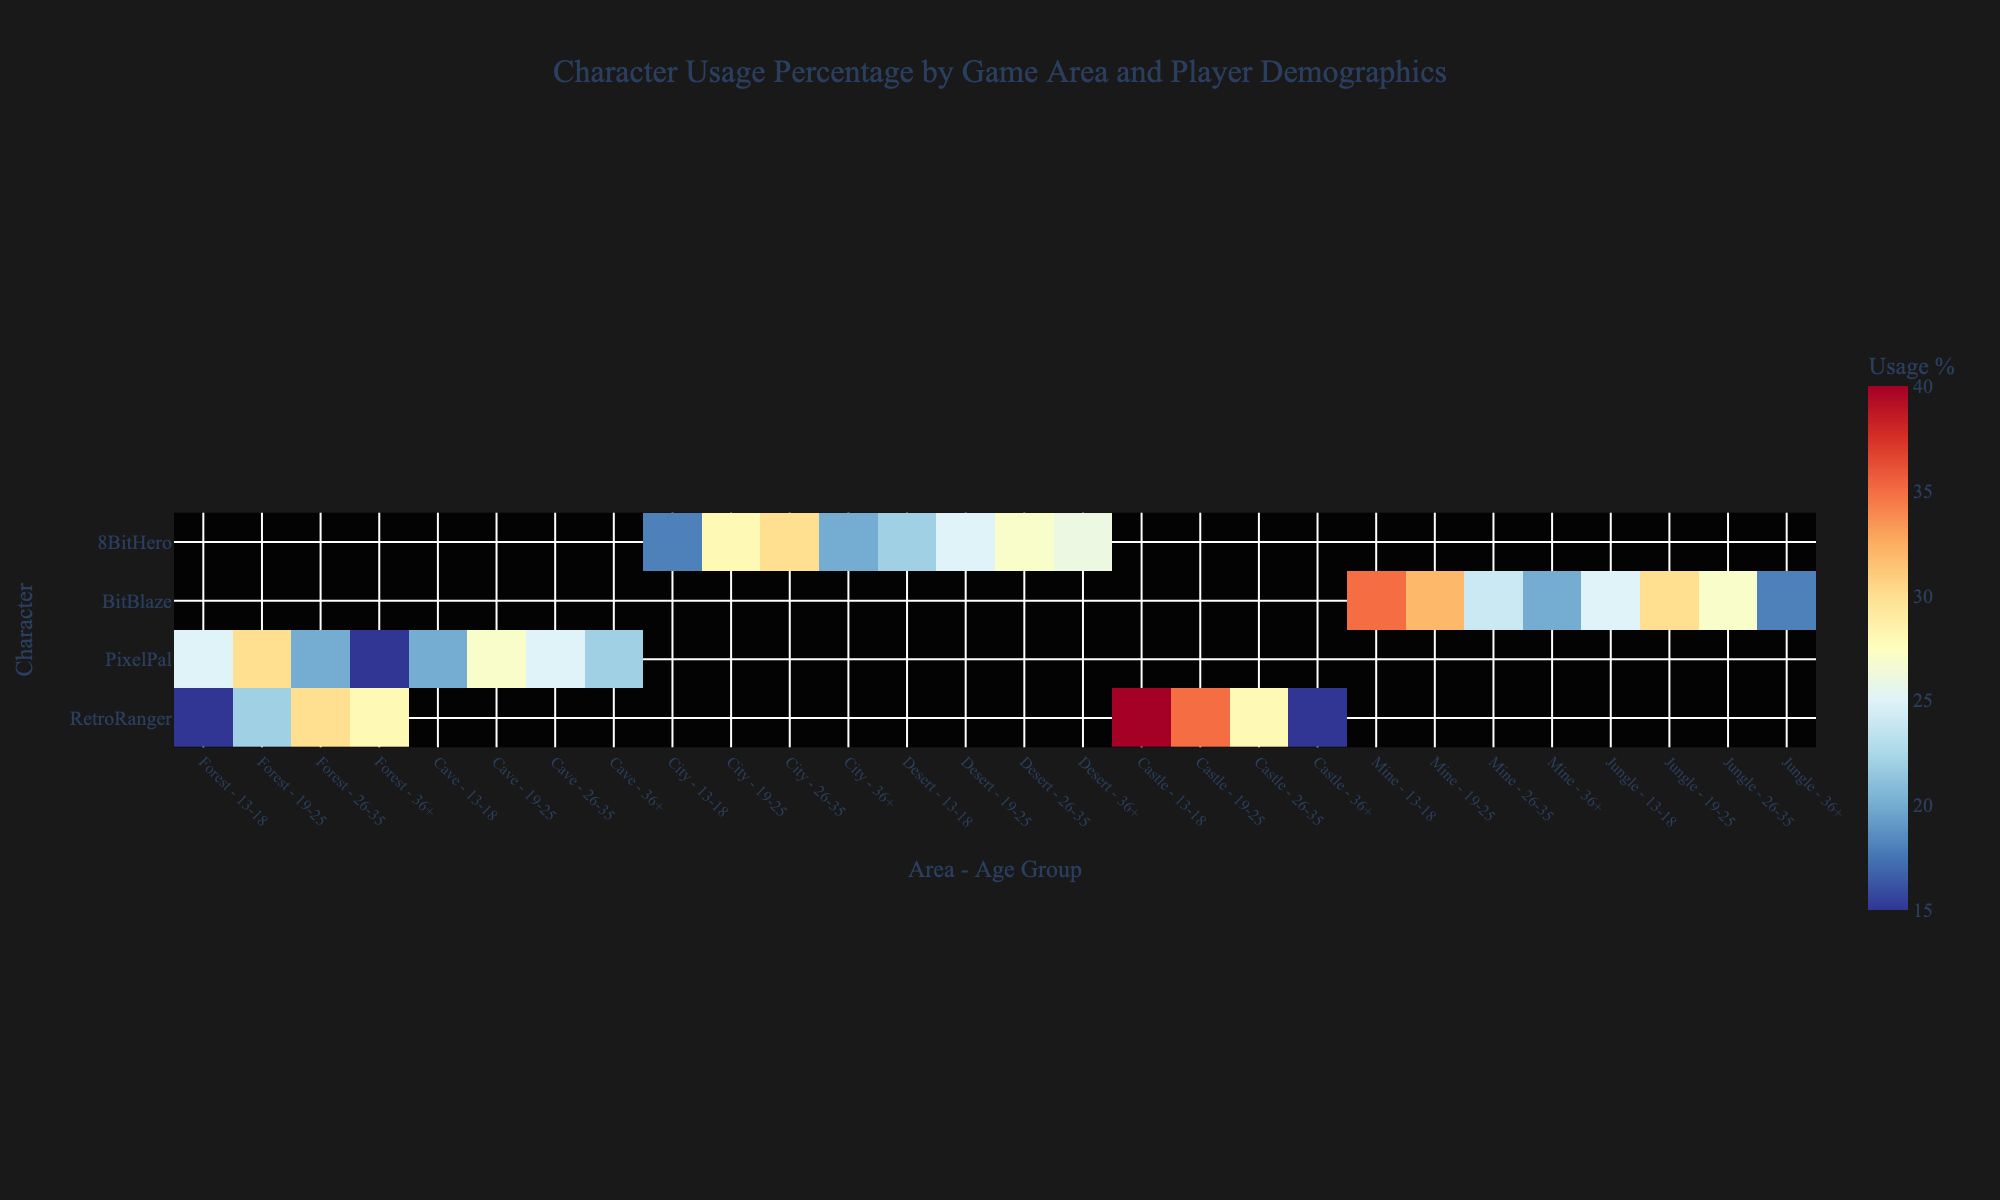What's the overall title of the figure? The title is usually found at the top of the heatmap, describing the main content or purpose of the visualization.
Answer: Character Usage Percentage by Game Area and Player Demographics Which character has the highest usage percentage in the Castle area? Look along the y-axis for 'RetroRanger,' then follow the relevant columns under Castle to find the highest percentage.
Answer: RetroRanger In the Forest area, which age group has the lowest usage percentage for PixelPal? Find the Forest column under PixelPal and compare the different age groups. The group with the lowest value is the one with the lowest usage percentage.
Answer: 36+ For 8BitHero, what's the difference in usage percentage between the youngest and oldest age groups in the City area? Locate 8BitHero and look at the City column. Subtract the usage percentage of the 36+ age group from the 13-18 age group.
Answer: 18 - 20 = -2 Which area shows the highest variability in character usage percentage for the 19-25 age group? Compare the heatmap values across all areas for the 19-25 age group. The area with the most uneven distribution (highest range) shows the highest variability.
Answer: Castle How does PixelPal's popularity in the Cave area compare across different age groups? Look at PixelPal's row and compare the values in the Cave columns for each age group.
Answer: 13-18: 20%, 19-25: 27%, 26-35: 25%, 36+: 22% Which character shows the most significant usage percentage increase when comparing the Jungle to Mine in the 13-18 age group? Compare each character's percentage in the Jungle and Mine areas for the 13-18 age group. The character with the largest positive difference shows the most significant increase.
Answer: BitBlaze What's the median usage percentage for all age groups in the Forest area for RetroRanger? List the usage percentages for all age groups for RetroRanger in Forest, then find the median. Percentages are 15, 22, 30, 28. Arrange them in ascending order, the median is (22+28)/2.
Answer: 25 In which area does 8BitHero have the closest usage percentage across all age groups? Evaluate the spread of 8BitHero's percentages in each area and find where the percentages are closest to each other.
Answer: Desert What color represents the highest usage percentage in the heatmap? Identify the color used for cells with the highest percentages by referring to the color axis legend.
Answer: Shade of Red 